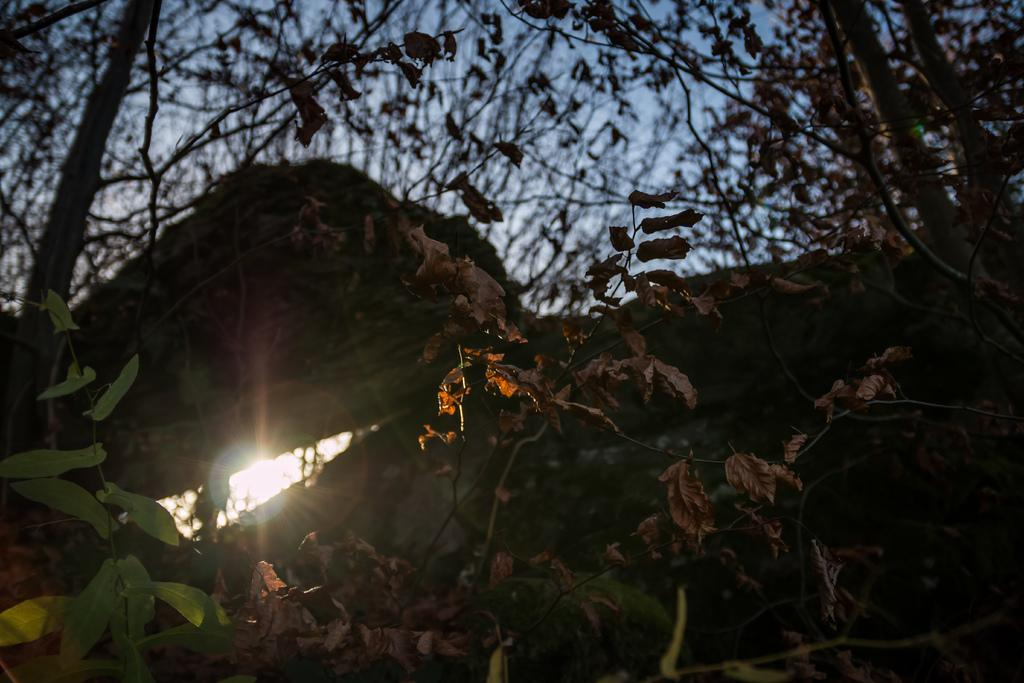What type of vegetation is present in the image? There are trees with branches and leaves in the image. Can these trees be classified as a specific type of living organism? Yes, these trees may be considered as plants. What additional feature can be seen in the image? There appears to be a light in the image. What type of window is visible in the image? There is no window present in the image. 